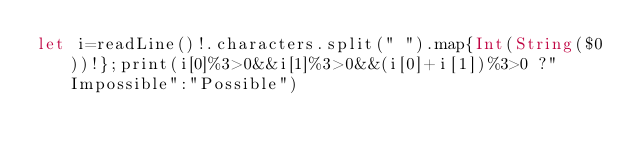<code> <loc_0><loc_0><loc_500><loc_500><_Swift_>let i=readLine()!.characters.split(" ").map{Int(String($0))!};print(i[0]%3>0&&i[1]%3>0&&(i[0]+i[1])%3>0 ?"Impossible":"Possible")</code> 